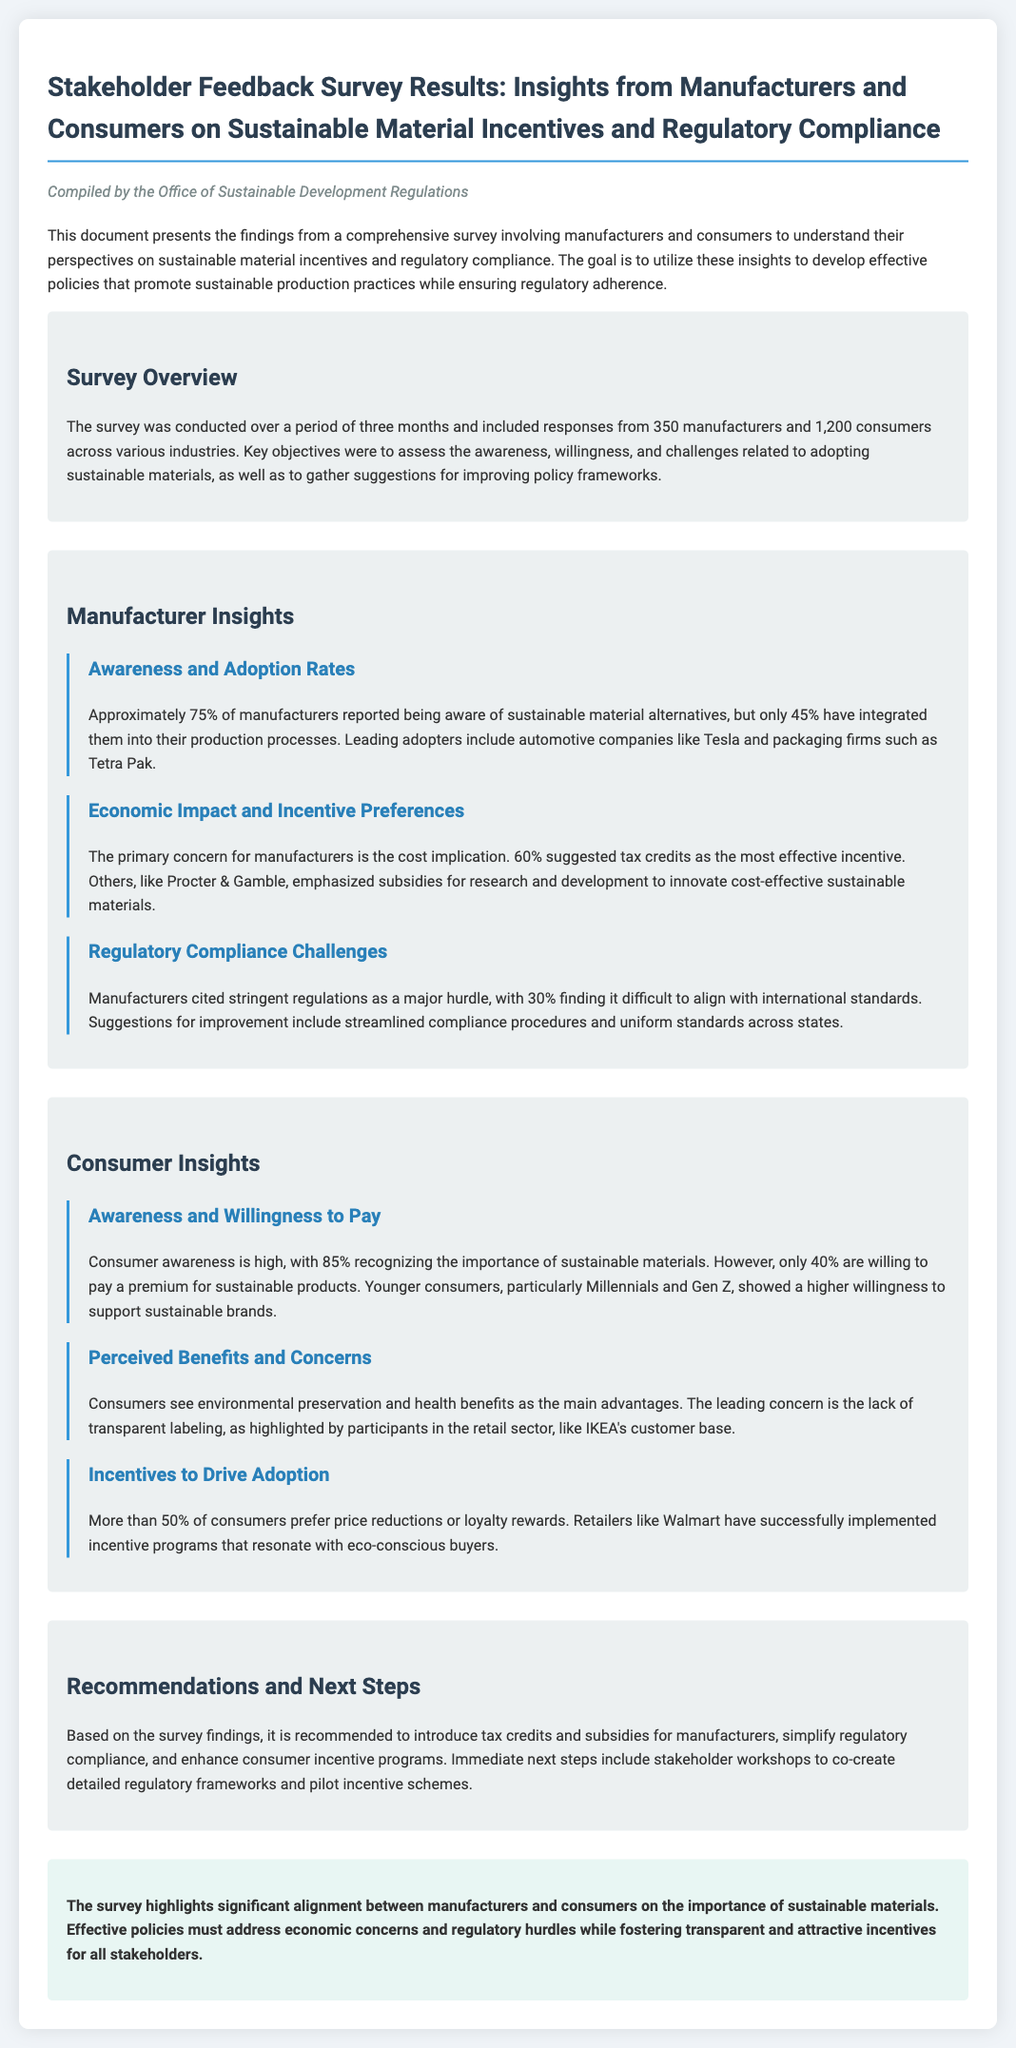What percentage of manufacturers reported awareness of sustainable material alternatives? The document states that approximately 75% of manufacturers reported being aware of sustainable material alternatives.
Answer: 75% What incentive did 60% of manufacturers suggest as the most effective? The document indicates that 60% of manufacturers suggested tax credits as the most effective incentive.
Answer: Tax credits What is the percentage of consumers willing to pay a premium for sustainable products? The document mentions that only 40% of consumers are willing to pay a premium for sustainable products.
Answer: 40% Which consumer group showed a higher willingness to support sustainable brands? The document highlights that younger consumers, particularly Millennials and Gen Z, showed a higher willingness to support sustainable brands.
Answer: Millennials and Gen Z What is the main concern consumers have about sustainable products? The leading concern among consumers is the lack of transparent labeling, as indicated in the document.
Answer: Lack of transparent labeling What are the recommended immediate next steps mentioned in the survey findings? The document recommends stakeholder workshops to co-create detailed regulatory frameworks and pilot incentive schemes as immediate next steps.
Answer: Stakeholder workshops What percentage of consumers prefer price reductions or loyalty rewards as incentives? The document states that more than 50% of consumers prefer price reductions or loyalty rewards.
Answer: More than 50% What do manufacturers emphasize as a significant hurdle regarding regulatory compliance? The document cites that 30% of manufacturers find it difficult to align with international standards as a major hurdle.
Answer: Difficulty to align with international standards 